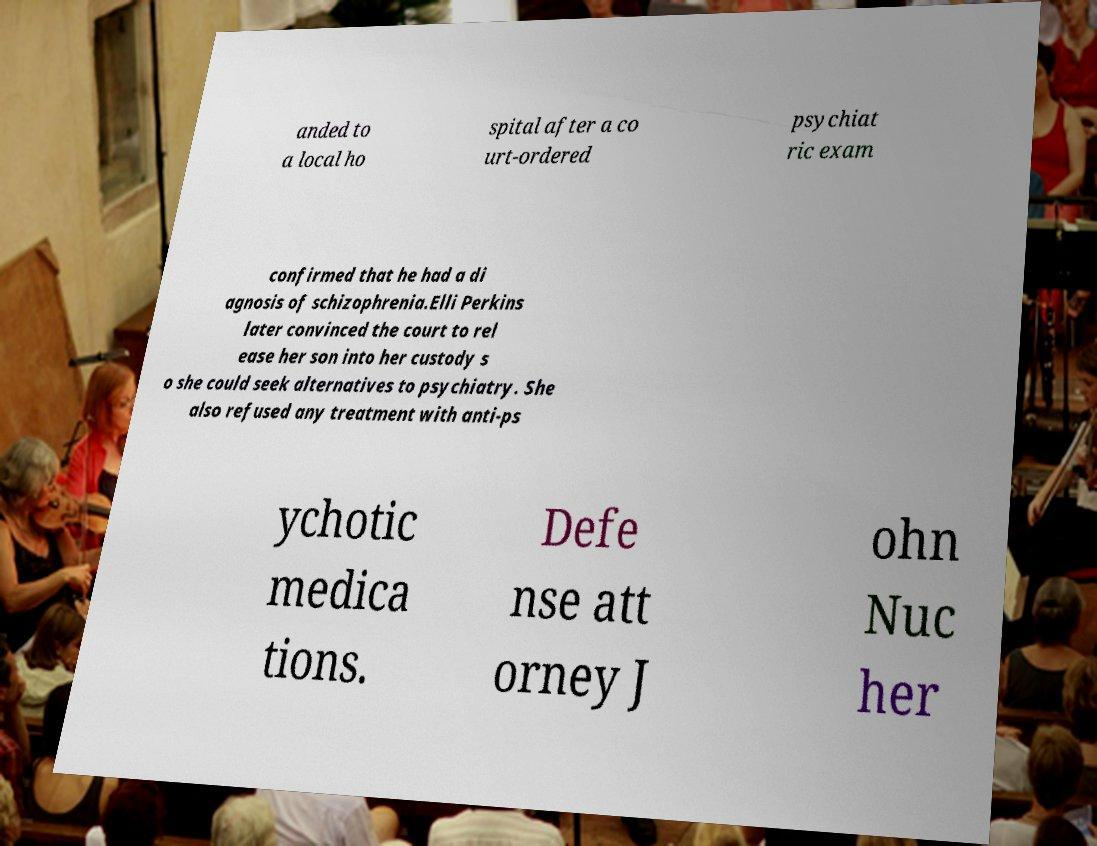There's text embedded in this image that I need extracted. Can you transcribe it verbatim? anded to a local ho spital after a co urt-ordered psychiat ric exam confirmed that he had a di agnosis of schizophrenia.Elli Perkins later convinced the court to rel ease her son into her custody s o she could seek alternatives to psychiatry. She also refused any treatment with anti-ps ychotic medica tions. Defe nse att orney J ohn Nuc her 